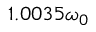Convert formula to latex. <formula><loc_0><loc_0><loc_500><loc_500>1 . 0 0 3 5 \omega _ { 0 }</formula> 